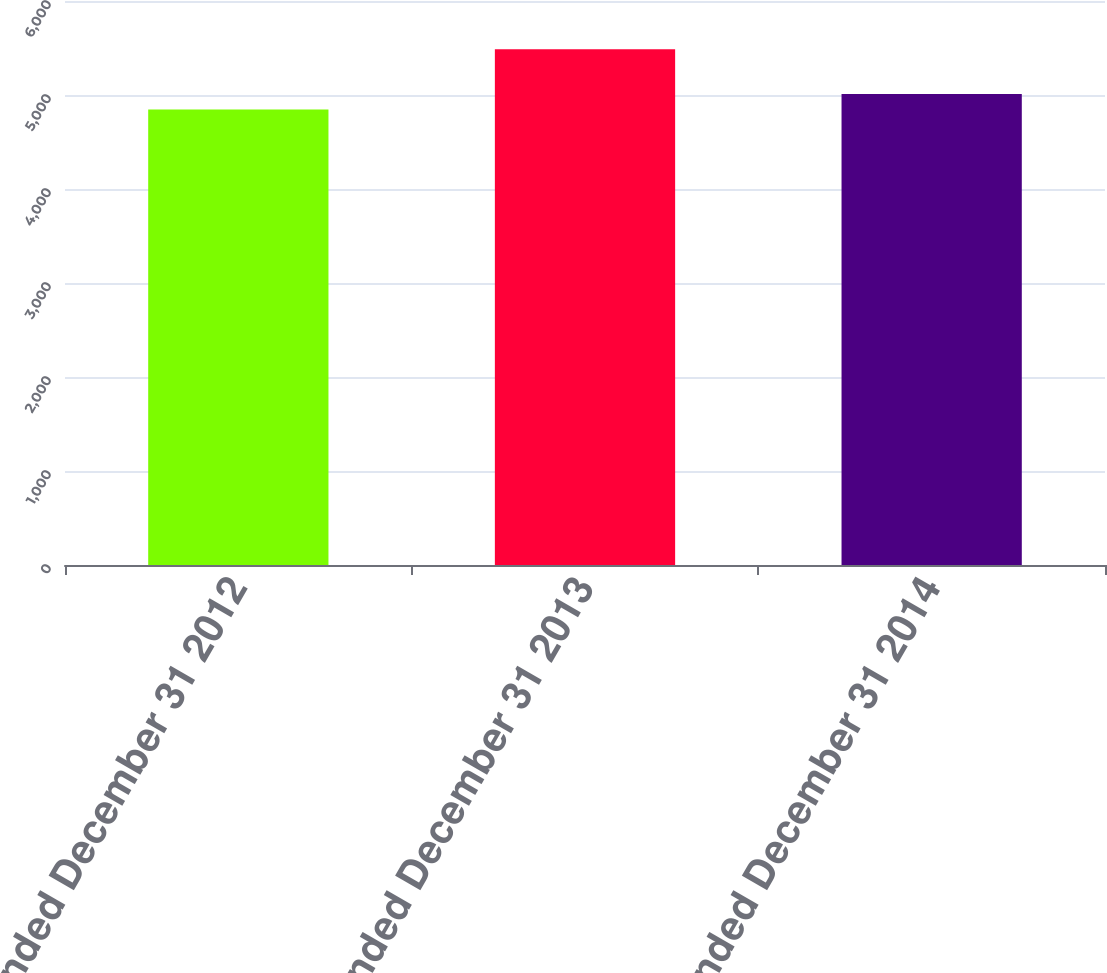<chart> <loc_0><loc_0><loc_500><loc_500><bar_chart><fcel>Year ended December 31 2012<fcel>Year ended December 31 2013<fcel>Year ended December 31 2014<nl><fcel>4846<fcel>5488<fcel>5011<nl></chart> 